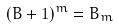<formula> <loc_0><loc_0><loc_500><loc_500>( B + 1 ) ^ { m } = B _ { m }</formula> 